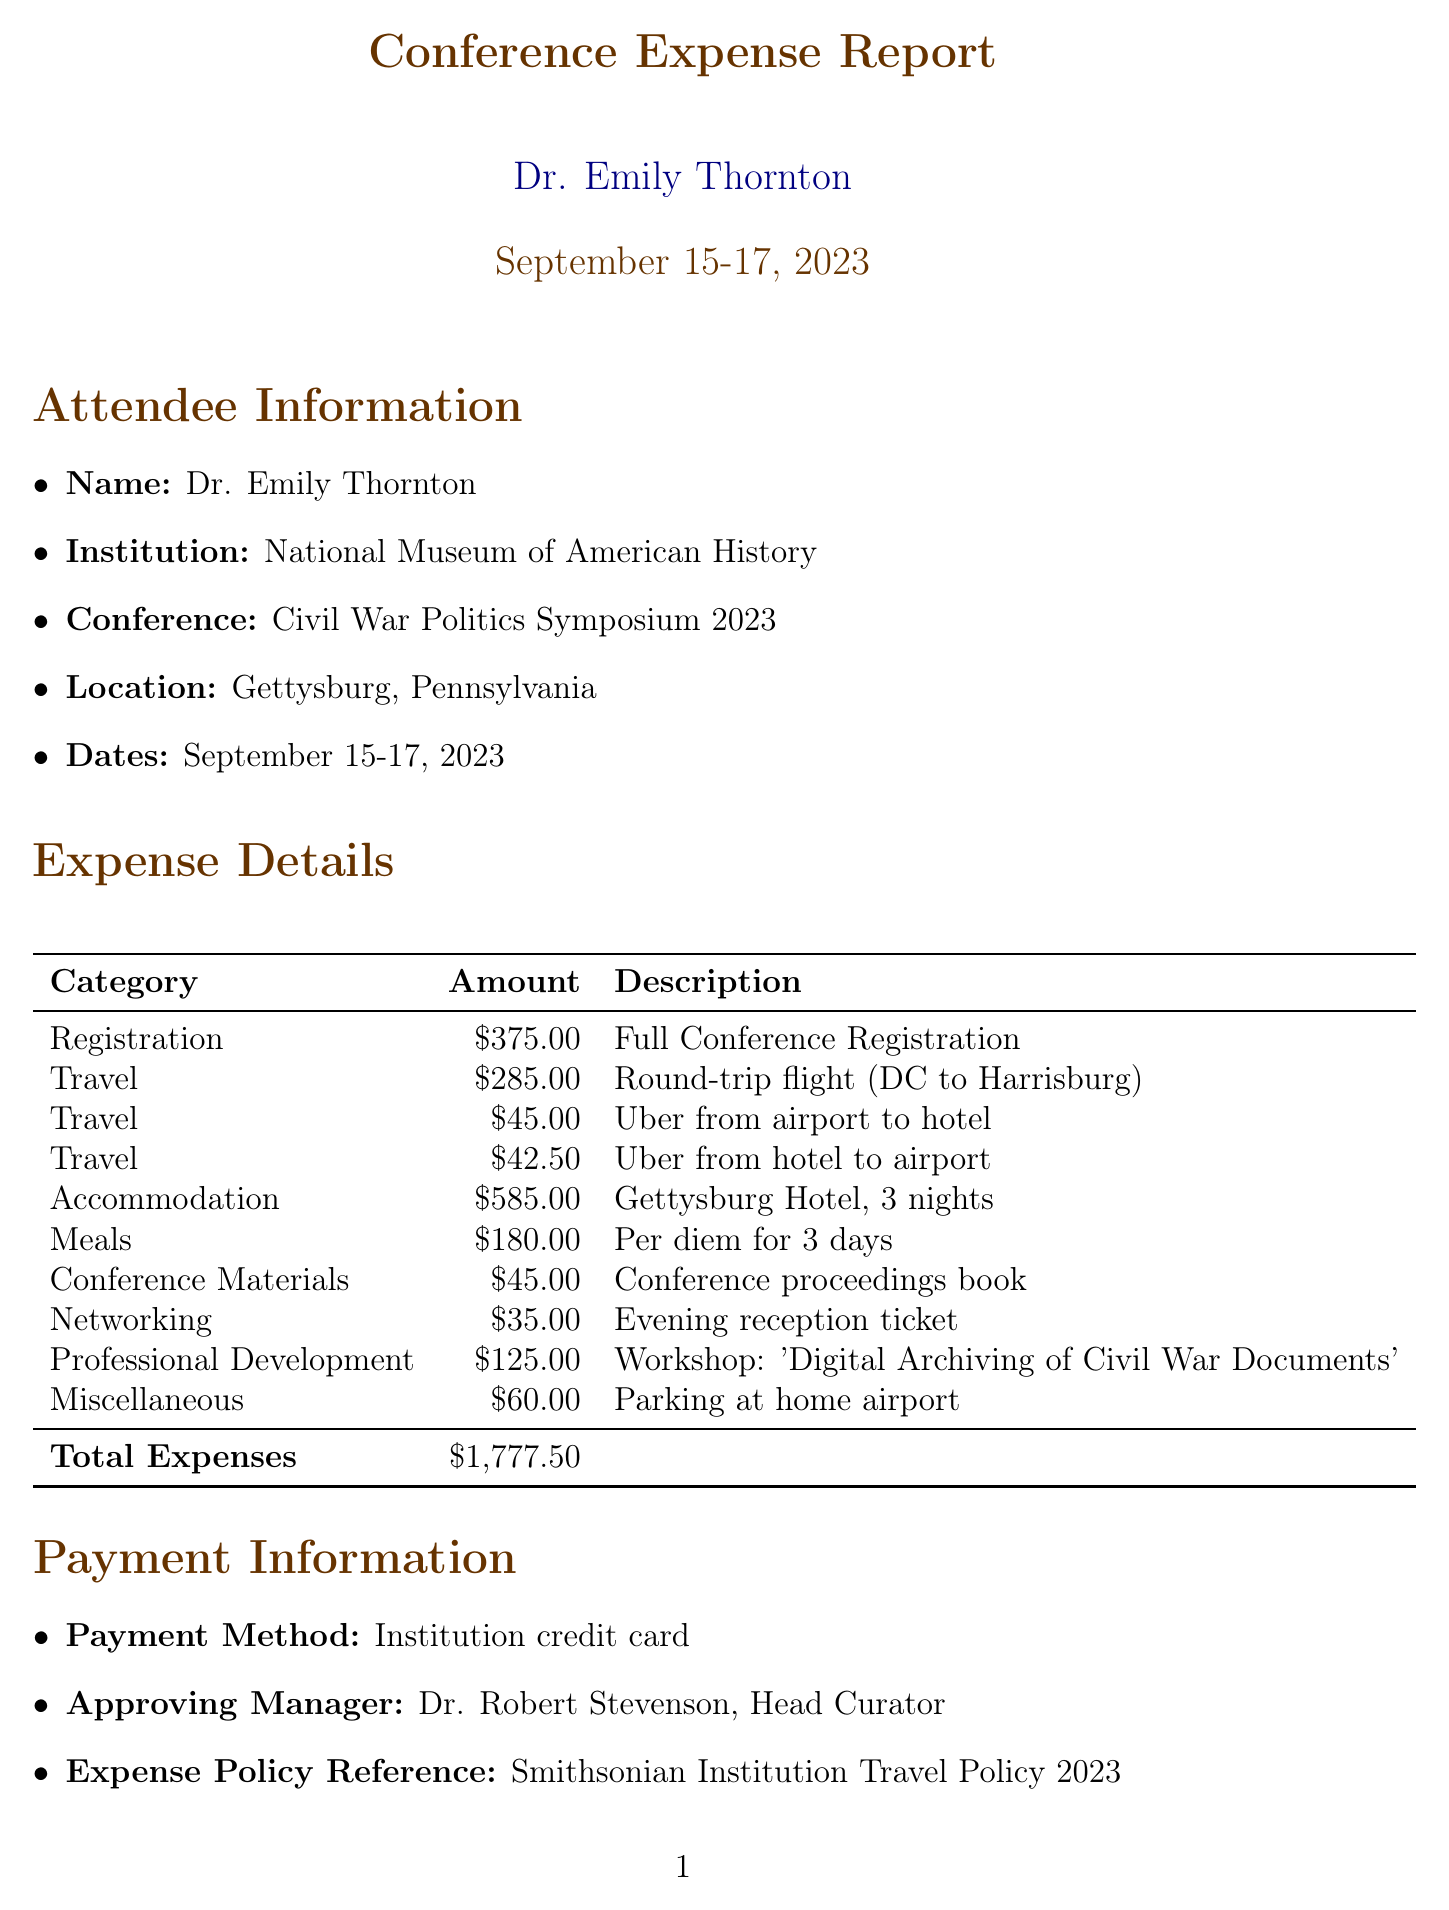what is the name of the conference? The name of the conference is provided in the title of the document as "Civil War Politics Symposium 2023."
Answer: Civil War Politics Symposium 2023 who is the attendee? The attendee's name is listed under the attendee information section.
Answer: Dr. Emily Thornton what is the total amount of expenses? The total expenses are calculated and presented at the bottom of the expense details table.
Answer: $1,777.50 how much was spent on accommodation? The amount spent on accommodation is specified in the expense details table under the accommodation category.
Answer: $585.00 what is the payment method used? The payment method is mentioned in the payment information section of the document.
Answer: Institution credit card who approved the expenses? The approving manager is indicated towards the end of the document, under payment information.
Answer: Dr. Robert Stevenson how many nights was the accommodation for? The accommodation description specifies the duration of stay in the hotel.
Answer: 3 nights what type of workshop was attended? The type of workshop is detailed in the professional development expense entry in the expense details table.
Answer: Digital Archiving of Civil War Documents in which city was the conference held? The city of the conference is mentioned under the conference location section.
Answer: Gettysburg, Pennsylvania 